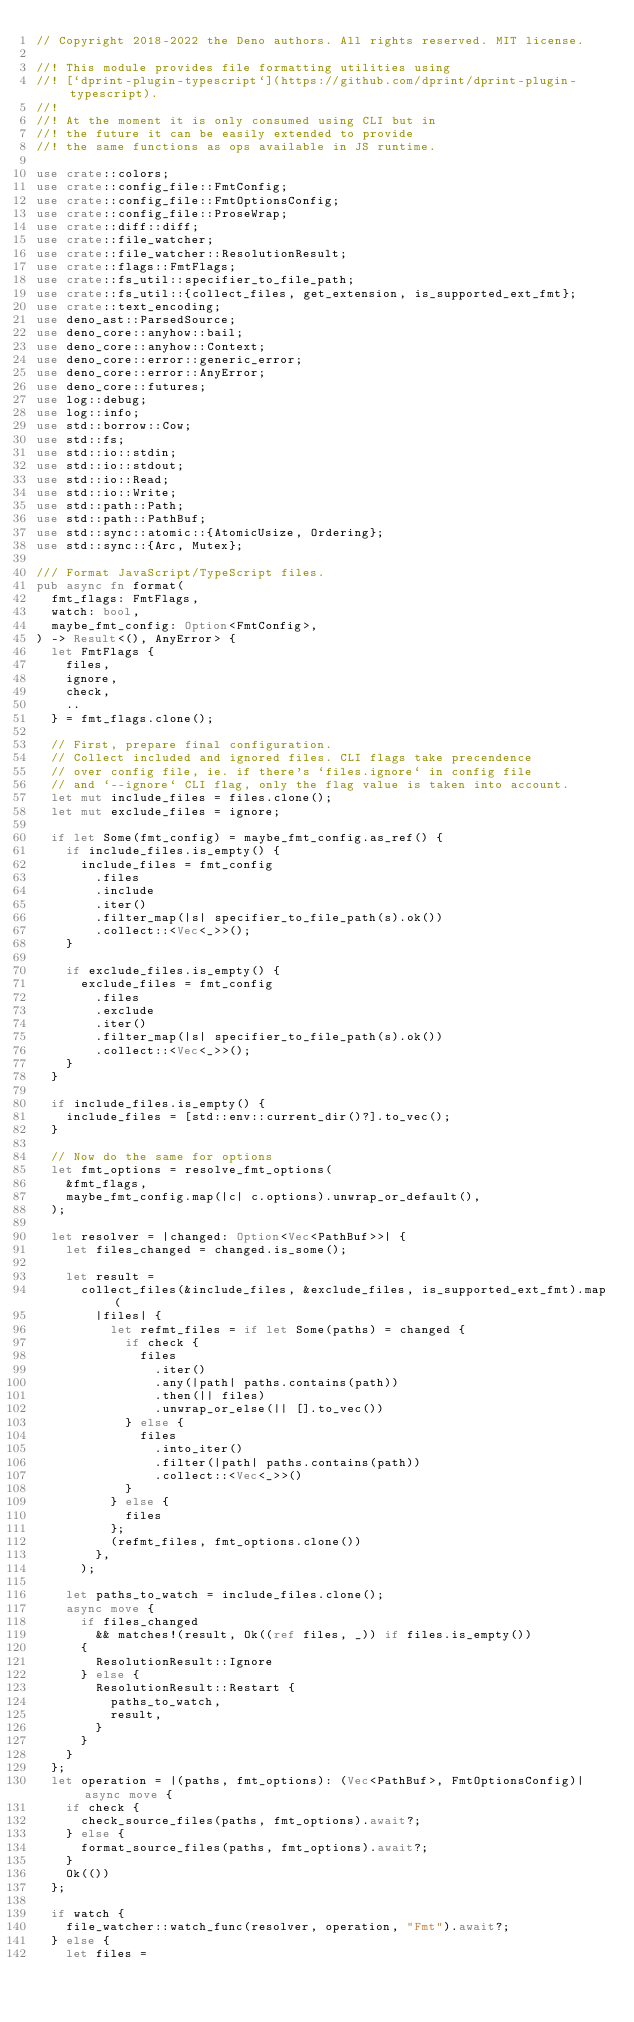<code> <loc_0><loc_0><loc_500><loc_500><_Rust_>// Copyright 2018-2022 the Deno authors. All rights reserved. MIT license.

//! This module provides file formatting utilities using
//! [`dprint-plugin-typescript`](https://github.com/dprint/dprint-plugin-typescript).
//!
//! At the moment it is only consumed using CLI but in
//! the future it can be easily extended to provide
//! the same functions as ops available in JS runtime.

use crate::colors;
use crate::config_file::FmtConfig;
use crate::config_file::FmtOptionsConfig;
use crate::config_file::ProseWrap;
use crate::diff::diff;
use crate::file_watcher;
use crate::file_watcher::ResolutionResult;
use crate::flags::FmtFlags;
use crate::fs_util::specifier_to_file_path;
use crate::fs_util::{collect_files, get_extension, is_supported_ext_fmt};
use crate::text_encoding;
use deno_ast::ParsedSource;
use deno_core::anyhow::bail;
use deno_core::anyhow::Context;
use deno_core::error::generic_error;
use deno_core::error::AnyError;
use deno_core::futures;
use log::debug;
use log::info;
use std::borrow::Cow;
use std::fs;
use std::io::stdin;
use std::io::stdout;
use std::io::Read;
use std::io::Write;
use std::path::Path;
use std::path::PathBuf;
use std::sync::atomic::{AtomicUsize, Ordering};
use std::sync::{Arc, Mutex};

/// Format JavaScript/TypeScript files.
pub async fn format(
  fmt_flags: FmtFlags,
  watch: bool,
  maybe_fmt_config: Option<FmtConfig>,
) -> Result<(), AnyError> {
  let FmtFlags {
    files,
    ignore,
    check,
    ..
  } = fmt_flags.clone();

  // First, prepare final configuration.
  // Collect included and ignored files. CLI flags take precendence
  // over config file, ie. if there's `files.ignore` in config file
  // and `--ignore` CLI flag, only the flag value is taken into account.
  let mut include_files = files.clone();
  let mut exclude_files = ignore;

  if let Some(fmt_config) = maybe_fmt_config.as_ref() {
    if include_files.is_empty() {
      include_files = fmt_config
        .files
        .include
        .iter()
        .filter_map(|s| specifier_to_file_path(s).ok())
        .collect::<Vec<_>>();
    }

    if exclude_files.is_empty() {
      exclude_files = fmt_config
        .files
        .exclude
        .iter()
        .filter_map(|s| specifier_to_file_path(s).ok())
        .collect::<Vec<_>>();
    }
  }

  if include_files.is_empty() {
    include_files = [std::env::current_dir()?].to_vec();
  }

  // Now do the same for options
  let fmt_options = resolve_fmt_options(
    &fmt_flags,
    maybe_fmt_config.map(|c| c.options).unwrap_or_default(),
  );

  let resolver = |changed: Option<Vec<PathBuf>>| {
    let files_changed = changed.is_some();

    let result =
      collect_files(&include_files, &exclude_files, is_supported_ext_fmt).map(
        |files| {
          let refmt_files = if let Some(paths) = changed {
            if check {
              files
                .iter()
                .any(|path| paths.contains(path))
                .then(|| files)
                .unwrap_or_else(|| [].to_vec())
            } else {
              files
                .into_iter()
                .filter(|path| paths.contains(path))
                .collect::<Vec<_>>()
            }
          } else {
            files
          };
          (refmt_files, fmt_options.clone())
        },
      );

    let paths_to_watch = include_files.clone();
    async move {
      if files_changed
        && matches!(result, Ok((ref files, _)) if files.is_empty())
      {
        ResolutionResult::Ignore
      } else {
        ResolutionResult::Restart {
          paths_to_watch,
          result,
        }
      }
    }
  };
  let operation = |(paths, fmt_options): (Vec<PathBuf>, FmtOptionsConfig)| async move {
    if check {
      check_source_files(paths, fmt_options).await?;
    } else {
      format_source_files(paths, fmt_options).await?;
    }
    Ok(())
  };

  if watch {
    file_watcher::watch_func(resolver, operation, "Fmt").await?;
  } else {
    let files =</code> 